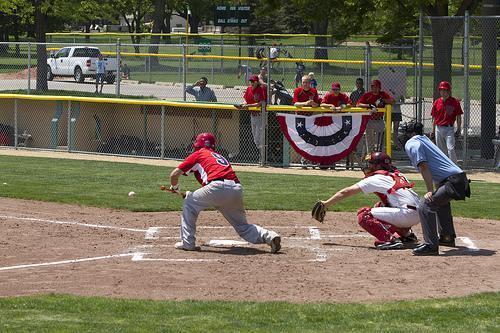How many people are wearing red shirts?
Give a very brief answer. 6. How many white trucks are there in the image ?
Give a very brief answer. 1. 